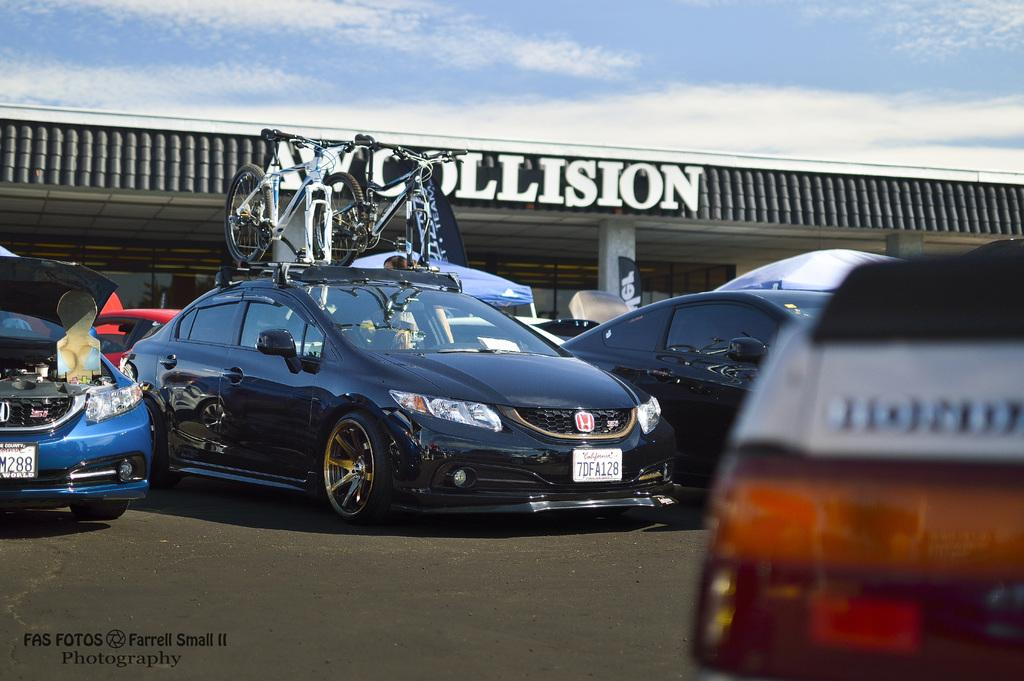<image>
Relay a brief, clear account of the picture shown. a car repair parking lot for AW Collision 